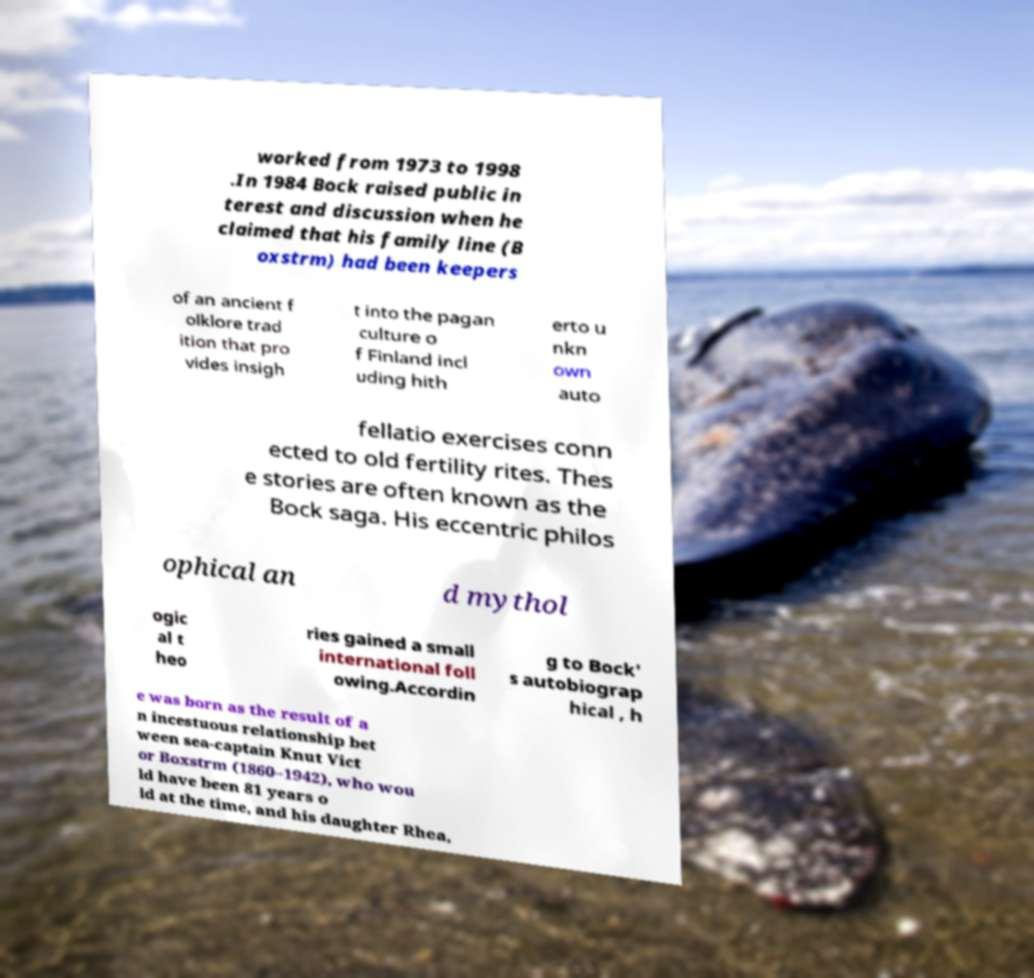Can you read and provide the text displayed in the image?This photo seems to have some interesting text. Can you extract and type it out for me? worked from 1973 to 1998 .In 1984 Bock raised public in terest and discussion when he claimed that his family line (B oxstrm) had been keepers of an ancient f olklore trad ition that pro vides insigh t into the pagan culture o f Finland incl uding hith erto u nkn own auto fellatio exercises conn ected to old fertility rites. Thes e stories are often known as the Bock saga. His eccentric philos ophical an d mythol ogic al t heo ries gained a small international foll owing.Accordin g to Bock' s autobiograp hical , h e was born as the result of a n incestuous relationship bet ween sea-captain Knut Vict or Boxstrm (1860–1942), who wou ld have been 81 years o ld at the time, and his daughter Rhea, 